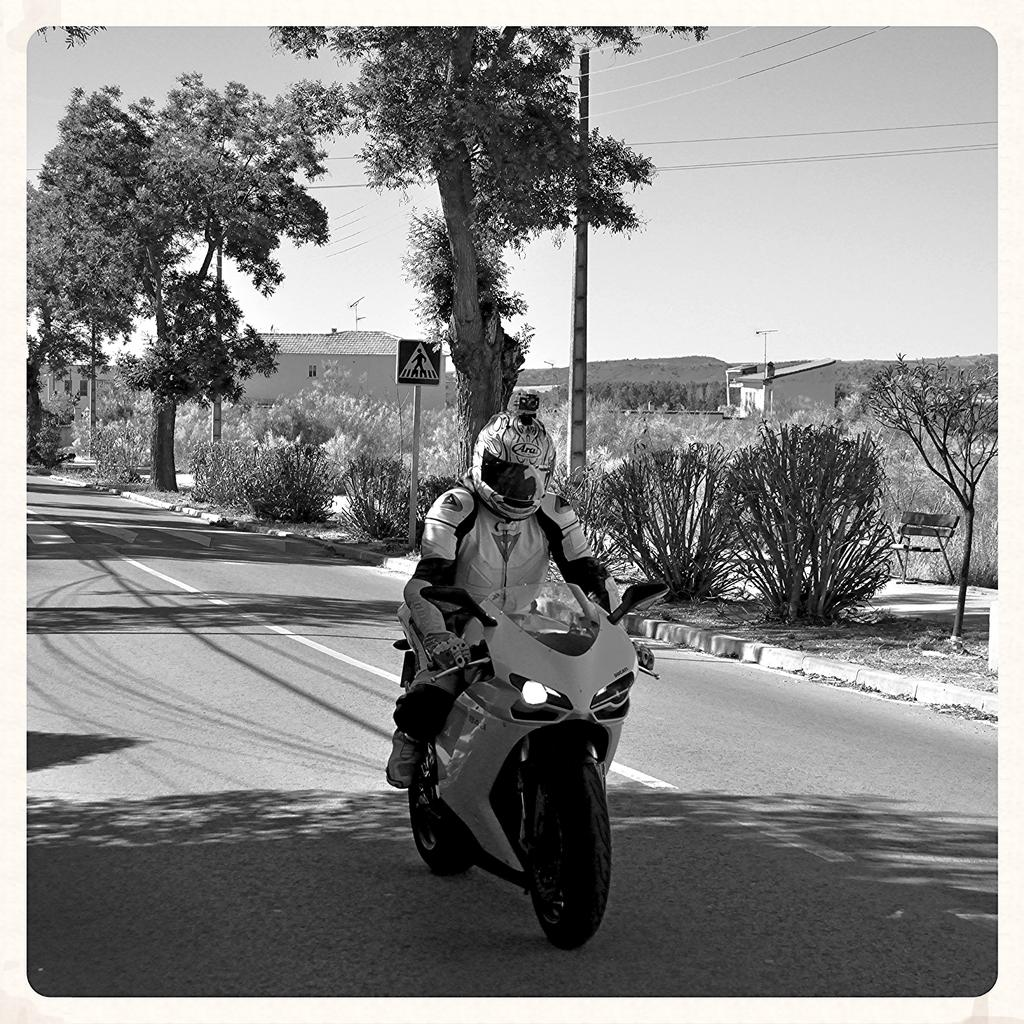What is the color scheme of the image? The image is black and white. What is the man in the image doing? The man is riding a bike on the road. What can be seen behind the man? There is a direction board behind the man. What type of vegetation is visible on the right side of the image? There are trees and bushes to the right side of the image. What else can be seen in the image besides the man and the direction board? There are wires visible in the image. What is visible in the background of the image? The sky is visible in the image. What type of grain can be seen growing in the image? There is no grain visible in the image; it is a black and white image of a man riding a bike on the road. 